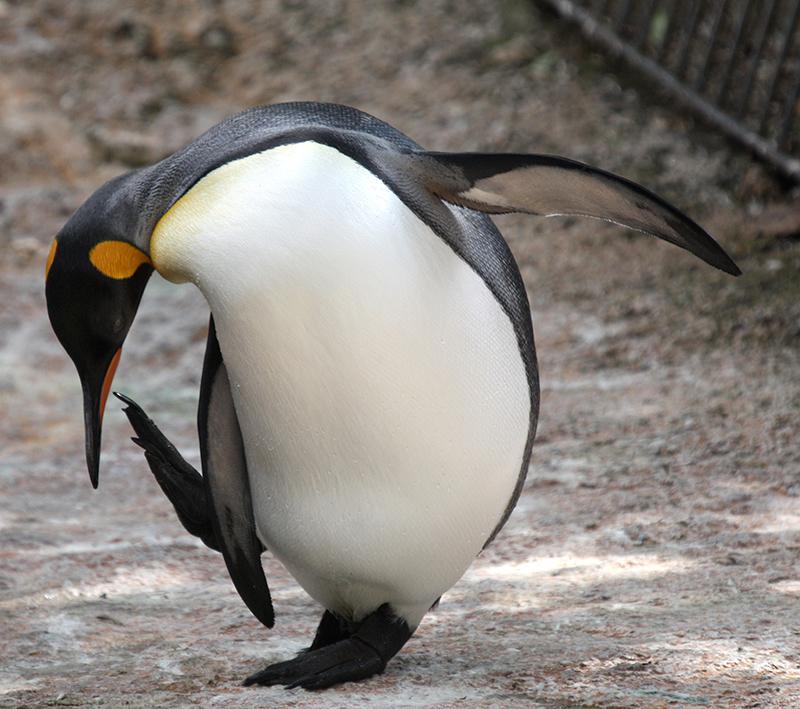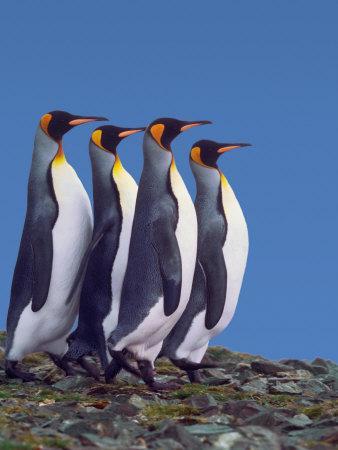The first image is the image on the left, the second image is the image on the right. Analyze the images presented: Is the assertion "One image contains just one penguin." valid? Answer yes or no. Yes. The first image is the image on the left, the second image is the image on the right. For the images displayed, is the sentence "There are five penguins" factually correct? Answer yes or no. Yes. 